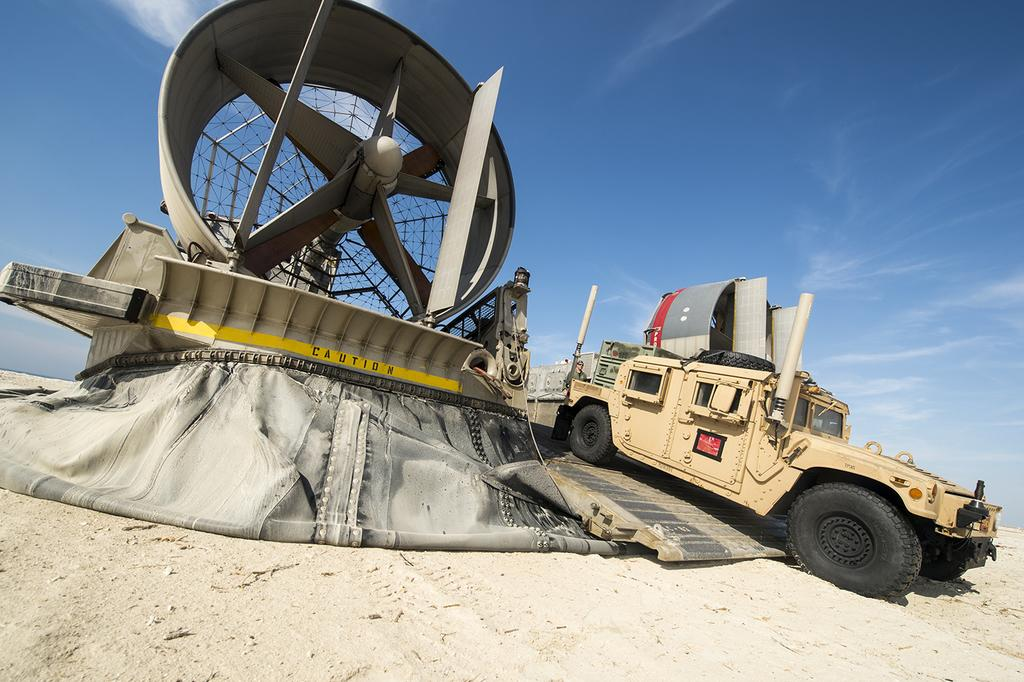What type of structure is visible in the image? There is an architecture in the image. What else can be seen on the ground in the image? There is a truck on the ground in the image. What is visible in the background of the image? The sky is visible in the image. How would you describe the weather based on the sky in the image? The sky appears to be cloudy in the image. Can you see the queen playing with a bat in the image? There is no queen or bat present in the image. 